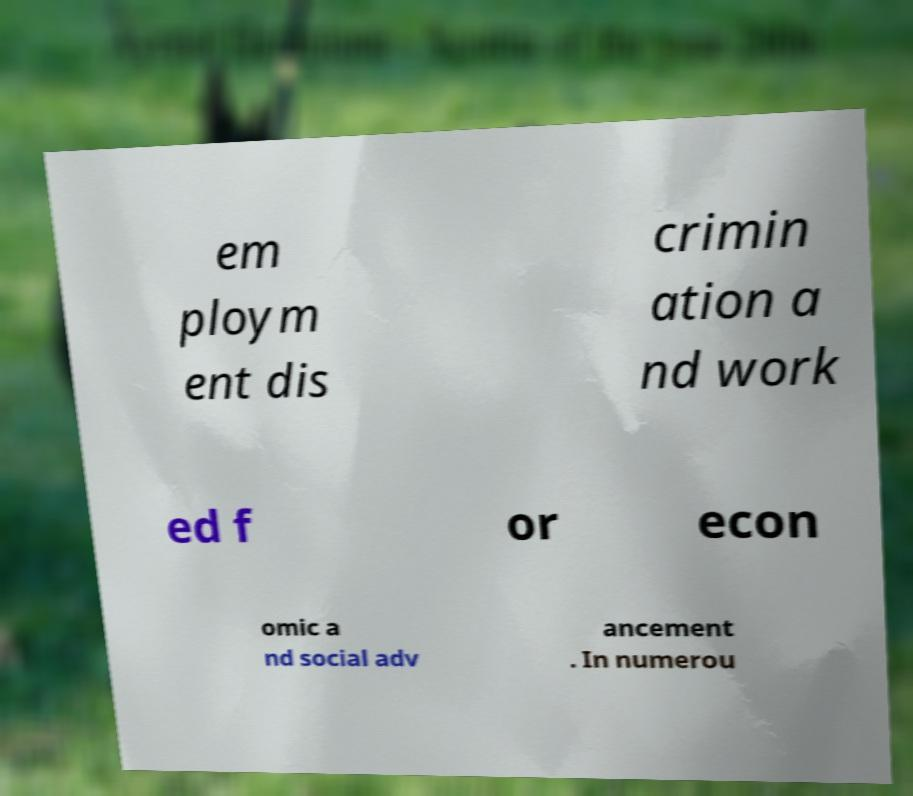There's text embedded in this image that I need extracted. Can you transcribe it verbatim? em ploym ent dis crimin ation a nd work ed f or econ omic a nd social adv ancement . In numerou 